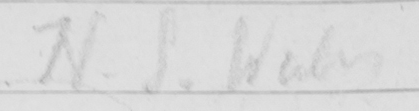Can you read and transcribe this handwriting? N . S . Wales 